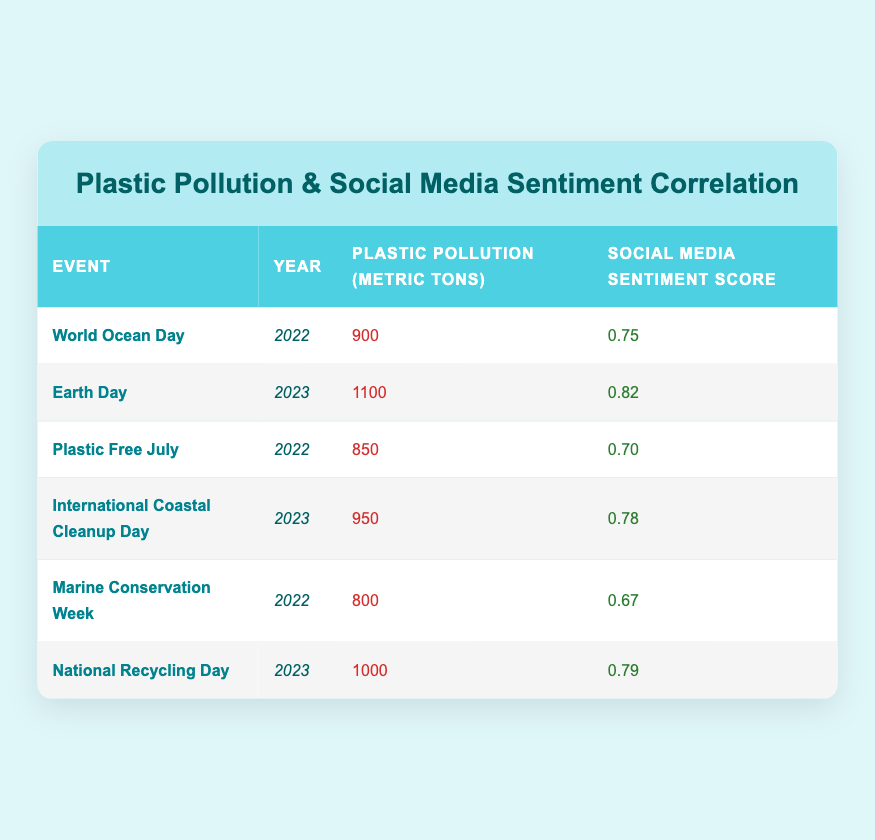What was the highest social media sentiment score recorded? The table lists social media sentiment scores for various events. The maximum score is 0.82, observed for Earth Day in 2023.
Answer: 0.82 Which event had the lowest plastic pollution metric tons? Looking through the plastic pollution column, the lowest value is 800 metric tons, which corresponds to Marine Conservation Week in 2022.
Answer: 800 Was the social media sentiment score higher for Earth Day than for World Ocean Day? The social media sentiment score for Earth Day (0.82) is compared with World Ocean Day (0.75). Since 0.82 is greater than 0.75, the sentiment score for Earth Day was indeed higher.
Answer: Yes What is the average plastic pollution in metric tons for the events listed in 2022? The plastic pollution values for 2022 are 900 (World Ocean Day), 850 (Plastic Free July), and 800 (Marine Conservation Week). Summing these values gives 900 + 850 + 800 = 2550. There are three events, so the average is 2550 / 3 = 850.
Answer: 850 Did the plastic pollution increase or decrease from Marine Conservation Week to Earth Day, considering their years? Marine Conservation Week had 800 metric tons in 2022, and Earth Day, which occurred in 2023, had 1100 metric tons. An increase is calculated as 1100 - 800 = 300 metric tons, indicating a rise in pollution.
Answer: Increase What is the total social media sentiment score for all events in 2023? The sentiment scores for events in 2023 are 0.82 (Earth Day), 0.78 (International Coastal Cleanup Day), and 0.79 (National Recycling Day). Adding them up gives 0.82 + 0.78 + 0.79 = 2.39.
Answer: 2.39 Which event corresponds to 950 metric tons of plastic pollution? By checking the table, the event with 950 metric tons of plastic pollution is International Coastal Cleanup Day in 2023.
Answer: International Coastal Cleanup Day Is the social media sentiment score consistently higher for events in 2023 compared to events in 2022? The sentiment scores for 2023 are 0.82, 0.78, and 0.79. For 2022, they are 0.75, 0.70, and 0.67. A quick comparison shows that all scores from 2023 (0.82, 0.78, 0.79) are higher than those from 2022 (0.75, 0.70, 0.67), confirming that sentiment scores are consistently higher in 2023.
Answer: Yes 